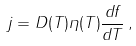<formula> <loc_0><loc_0><loc_500><loc_500>j = D ( T ) \eta ( T ) \frac { d f } { d T } \, ,</formula> 